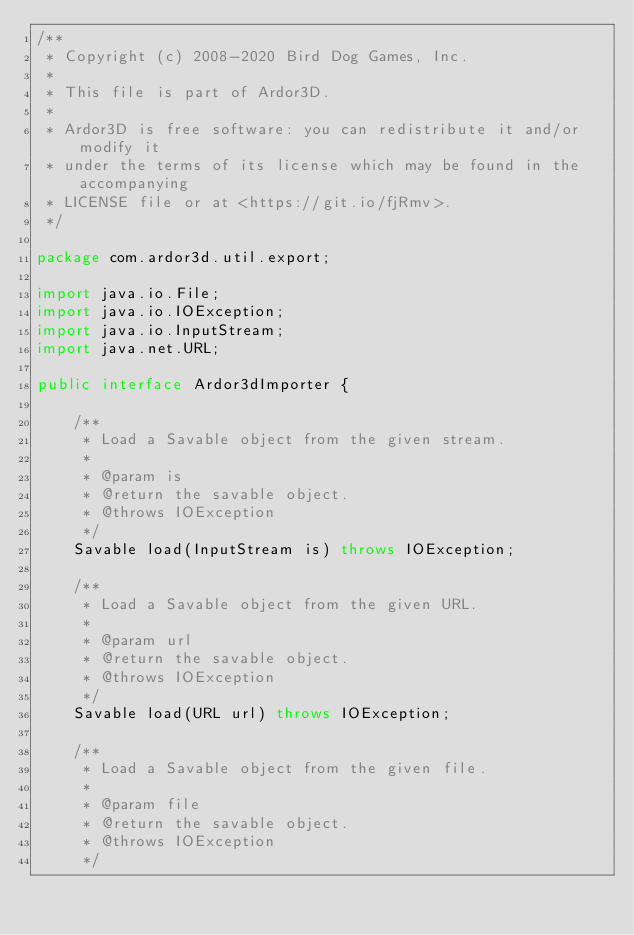<code> <loc_0><loc_0><loc_500><loc_500><_Java_>/**
 * Copyright (c) 2008-2020 Bird Dog Games, Inc.
 *
 * This file is part of Ardor3D.
 *
 * Ardor3D is free software: you can redistribute it and/or modify it 
 * under the terms of its license which may be found in the accompanying
 * LICENSE file or at <https://git.io/fjRmv>.
 */

package com.ardor3d.util.export;

import java.io.File;
import java.io.IOException;
import java.io.InputStream;
import java.net.URL;

public interface Ardor3dImporter {

    /**
     * Load a Savable object from the given stream.
     * 
     * @param is
     * @return the savable object.
     * @throws IOException
     */
    Savable load(InputStream is) throws IOException;

    /**
     * Load a Savable object from the given URL.
     * 
     * @param url
     * @return the savable object.
     * @throws IOException
     */
    Savable load(URL url) throws IOException;

    /**
     * Load a Savable object from the given file.
     * 
     * @param file
     * @return the savable object.
     * @throws IOException
     */</code> 